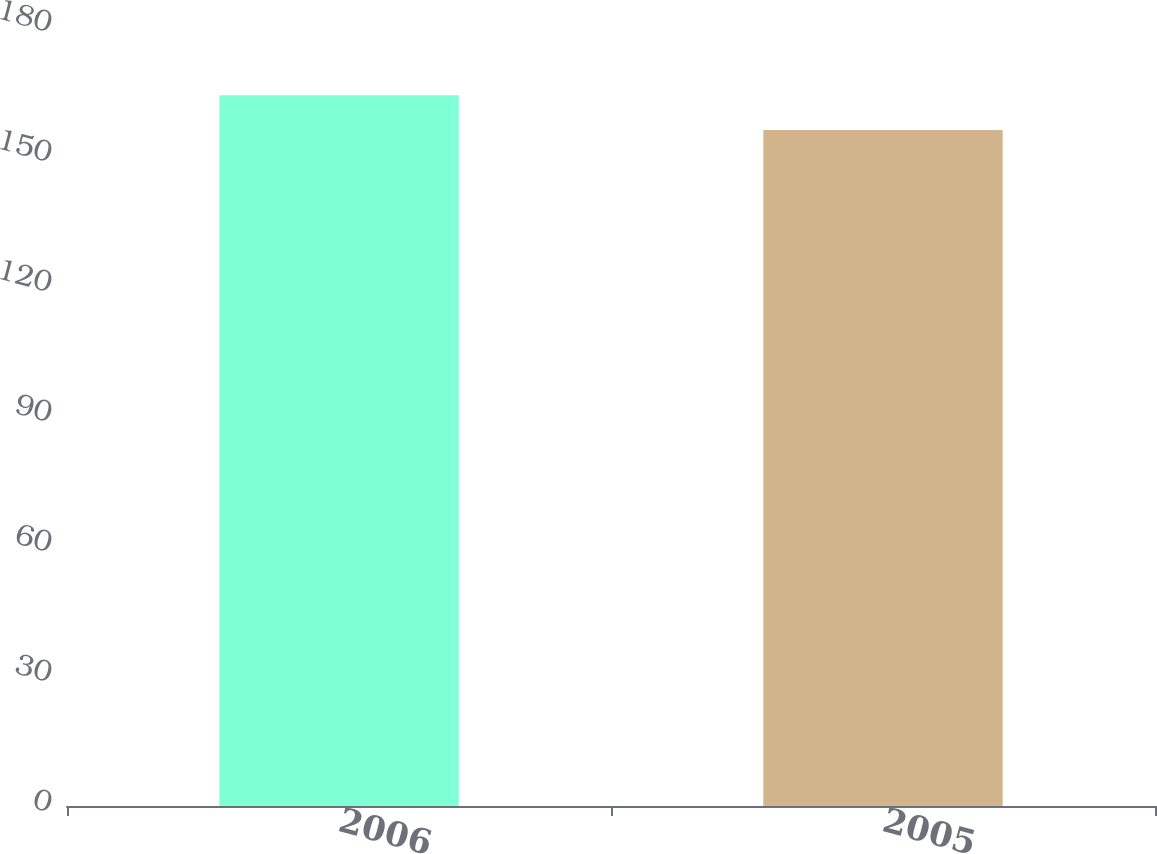<chart> <loc_0><loc_0><loc_500><loc_500><bar_chart><fcel>2006<fcel>2005<nl><fcel>164<fcel>156<nl></chart> 